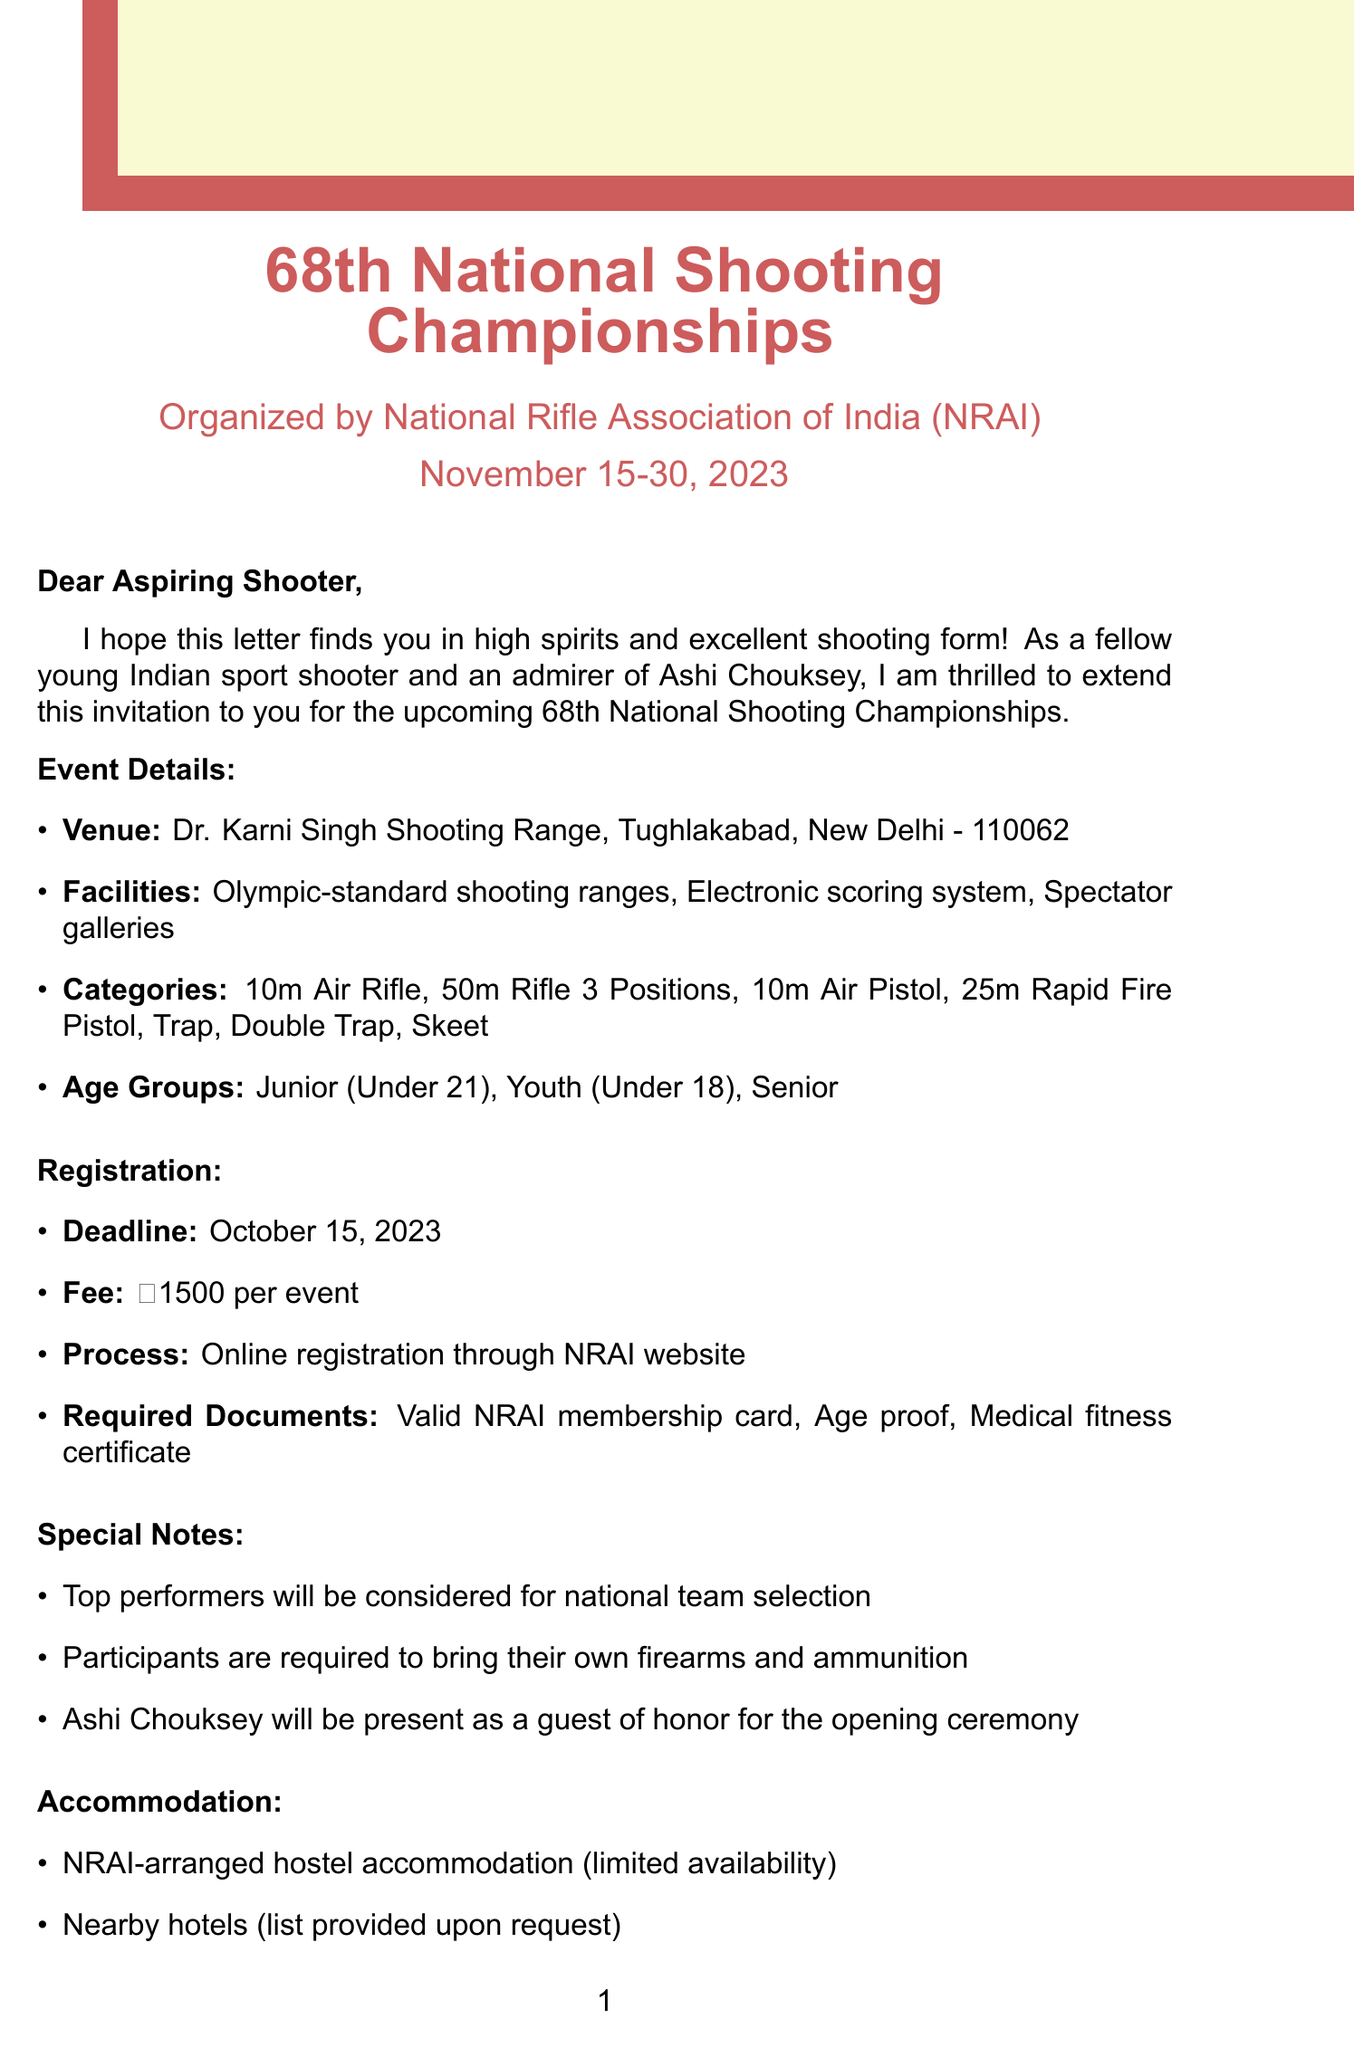What is the event name? The event name is explicitly mentioned in the document as the main title at the top.
Answer: 68th National Shooting Championships Who is organizing the event? The organizer is stated immediately after the event name in the document.
Answer: National Rifle Association of India (NRAI) What is the event registration deadline? The registration deadline is specified in the registration section of the document.
Answer: October 15, 2023 What is the registration fee per event? The fee is listed alongside the registration details in the document.
Answer: ₹1500 per event Which age group is considered Junior? The age categories are listed in the event details section, mentioning the specific criteria for age groups.
Answer: Under 21 What facilities are available at the venue? The facilities are described in a bullet list under the venue information in the document.
Answer: Olympic-standard shooting ranges, Electronic scoring system, Spectator galleries What documents are required for registration? The required documents are enumerated in the registration section of the document.
Answer: Valid NRAI membership card, Age proof, Medical fitness certificate Who is the contact person for queries? The contact person is mentioned towards the end of the document with their designation.
Answer: Mr. Rajiv Bhatia What special note is mentioned regarding Ashi Chouksey? The special notes section includes a mention of Ashi Chouksey's role during the event.
Answer: Guest of honor for the opening ceremony 